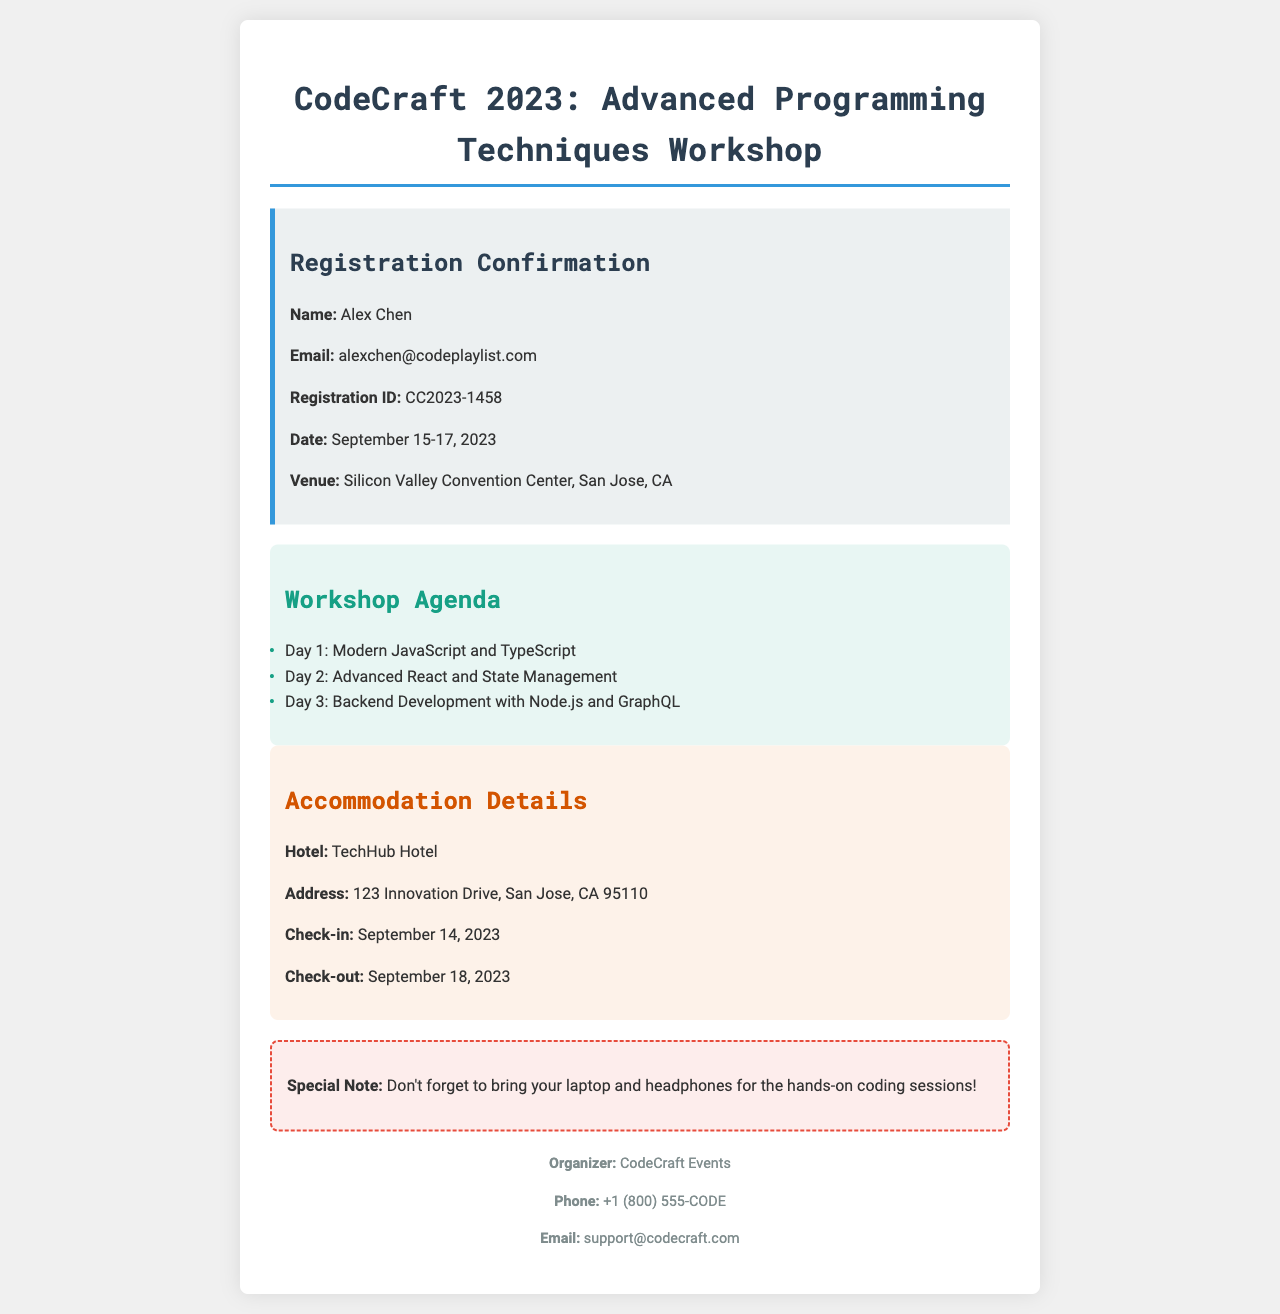What is the workshop title? The workshop title is provided at the beginning of the document as "CodeCraft 2023: Advanced Programming Techniques Workshop."
Answer: Advanced Programming Techniques Workshop Who is registered for the workshop? The document lists the name of the registered attendee, which is "Alex Chen."
Answer: Alex Chen What are the workshop dates? The registration confirmation includes the dates of the workshop, stated as "September 15-17, 2023."
Answer: September 15-17, 2023 What is the name of the hotel for accommodation? The accommodation section mentions the hotel name as "TechHub Hotel."
Answer: TechHub Hotel What topic is covered on Day 2 of the workshop? The agenda lists the topics covered each day, and Day 2 is "Advanced React and State Management."
Answer: Advanced React and State Management What is the check-out date for the accommodation? The accommodation details specify the check-out date as "September 18, 2023."
Answer: September 18, 2023 What is the email for support? The contact section provides an email address for inquiries, which is "support@codecraft.com."
Answer: support@codecraft.com What should attendees bring to the workshop? A special note in the document advises attendees to bring "laptop and headphones."
Answer: laptop and headphones What is the venue of the workshop? The workshop venue is stated as "Silicon Valley Convention Center, San Jose, CA."
Answer: Silicon Valley Convention Center, San Jose, CA 